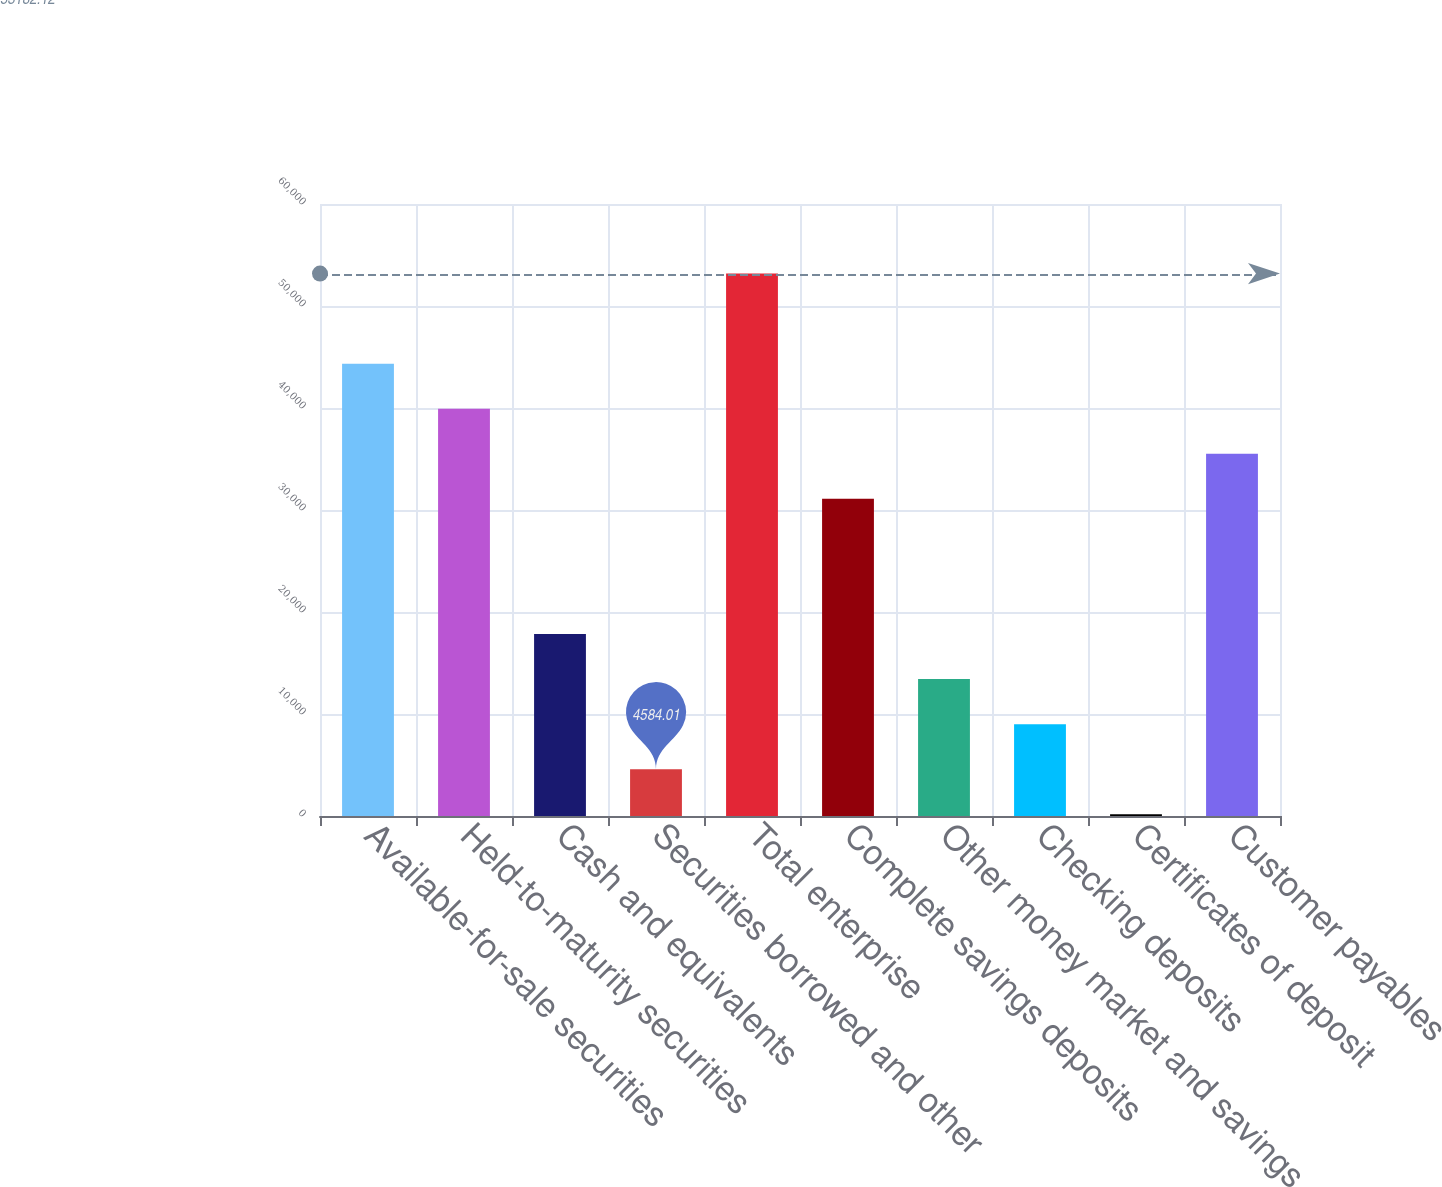Convert chart to OTSL. <chart><loc_0><loc_0><loc_500><loc_500><bar_chart><fcel>Available-for-sale securities<fcel>Held-to-maturity securities<fcel>Cash and equivalents<fcel>Securities borrowed and other<fcel>Total enterprise<fcel>Complete savings deposits<fcel>Other money market and savings<fcel>Checking deposits<fcel>Certificates of deposit<fcel>Customer payables<nl><fcel>44346.1<fcel>39928.1<fcel>17838<fcel>4584.01<fcel>53182.1<fcel>31092.1<fcel>13420<fcel>9002.02<fcel>166<fcel>35510.1<nl></chart> 